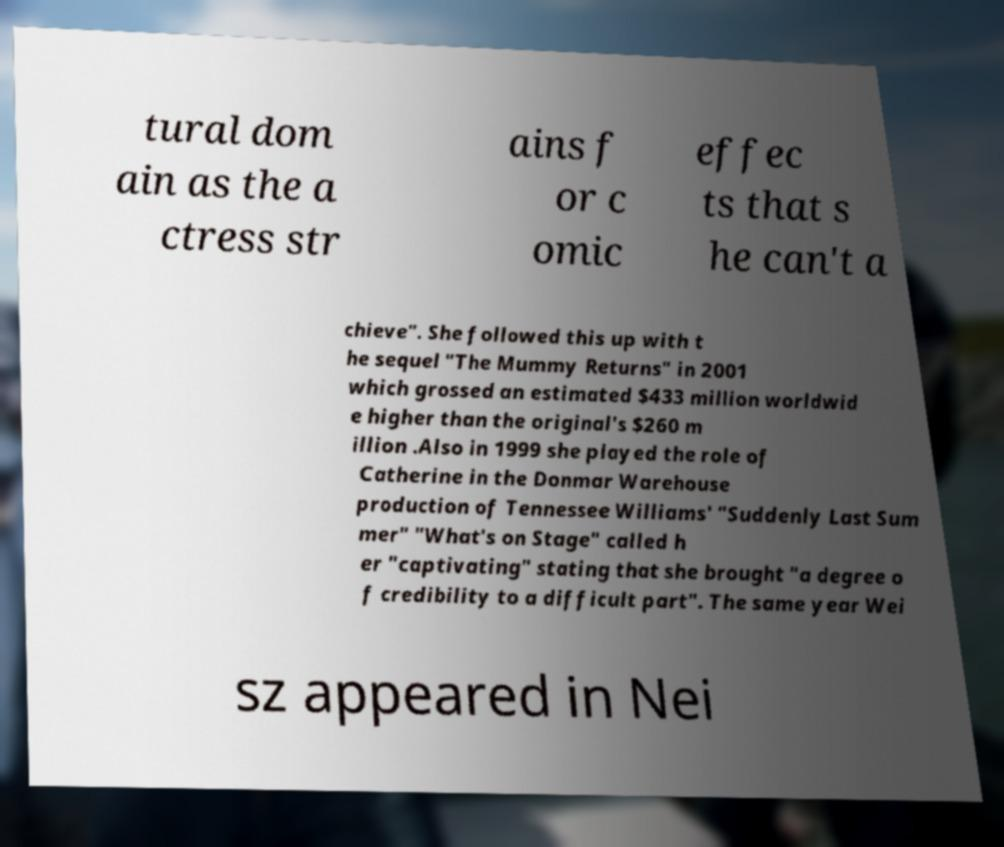For documentation purposes, I need the text within this image transcribed. Could you provide that? tural dom ain as the a ctress str ains f or c omic effec ts that s he can't a chieve". She followed this up with t he sequel "The Mummy Returns" in 2001 which grossed an estimated $433 million worldwid e higher than the original's $260 m illion .Also in 1999 she played the role of Catherine in the Donmar Warehouse production of Tennessee Williams' "Suddenly Last Sum mer" "What's on Stage" called h er "captivating" stating that she brought "a degree o f credibility to a difficult part". The same year Wei sz appeared in Nei 